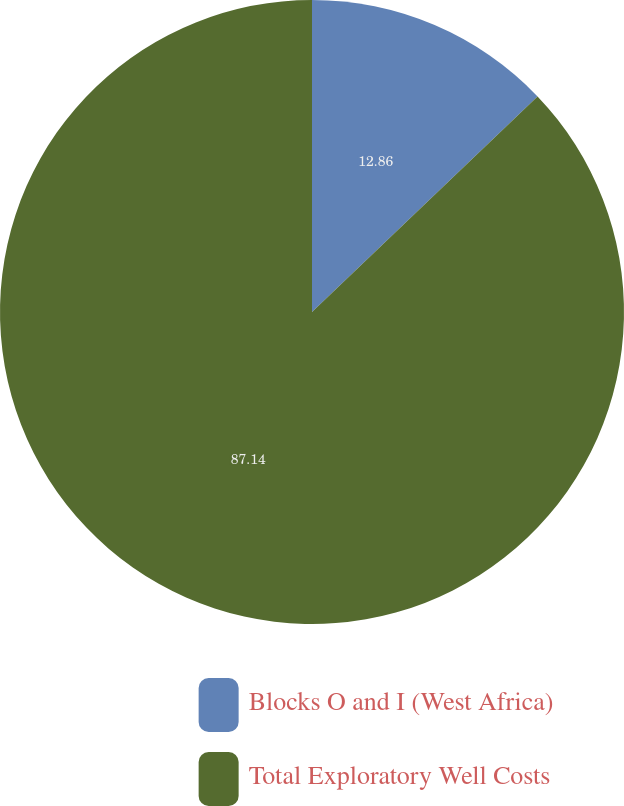Convert chart to OTSL. <chart><loc_0><loc_0><loc_500><loc_500><pie_chart><fcel>Blocks O and I (West Africa)<fcel>Total Exploratory Well Costs<nl><fcel>12.86%<fcel>87.14%<nl></chart> 